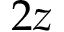Convert formula to latex. <formula><loc_0><loc_0><loc_500><loc_500>2 z</formula> 